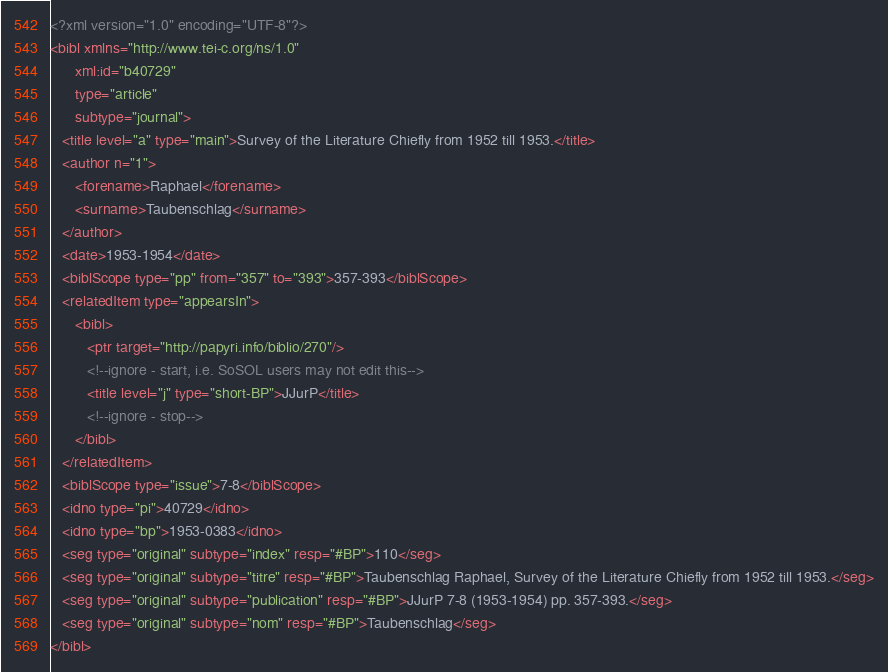Convert code to text. <code><loc_0><loc_0><loc_500><loc_500><_XML_><?xml version="1.0" encoding="UTF-8"?>
<bibl xmlns="http://www.tei-c.org/ns/1.0"
      xml:id="b40729"
      type="article"
      subtype="journal">
   <title level="a" type="main">Survey of the Literature Chiefly from 1952 till 1953.</title>
   <author n="1">
      <forename>Raphael</forename>
      <surname>Taubenschlag</surname>
   </author>
   <date>1953-1954</date>
   <biblScope type="pp" from="357" to="393">357-393</biblScope>
   <relatedItem type="appearsIn">
      <bibl>
         <ptr target="http://papyri.info/biblio/270"/>
         <!--ignore - start, i.e. SoSOL users may not edit this-->
         <title level="j" type="short-BP">JJurP</title>
         <!--ignore - stop-->
      </bibl>
   </relatedItem>
   <biblScope type="issue">7-8</biblScope>
   <idno type="pi">40729</idno>
   <idno type="bp">1953-0383</idno>
   <seg type="original" subtype="index" resp="#BP">110</seg>
   <seg type="original" subtype="titre" resp="#BP">Taubenschlag Raphael, Survey of the Literature Chiefly from 1952 till 1953.</seg>
   <seg type="original" subtype="publication" resp="#BP">JJurP 7-8 (1953-1954) pp. 357-393.</seg>
   <seg type="original" subtype="nom" resp="#BP">Taubenschlag</seg>
</bibl>
</code> 